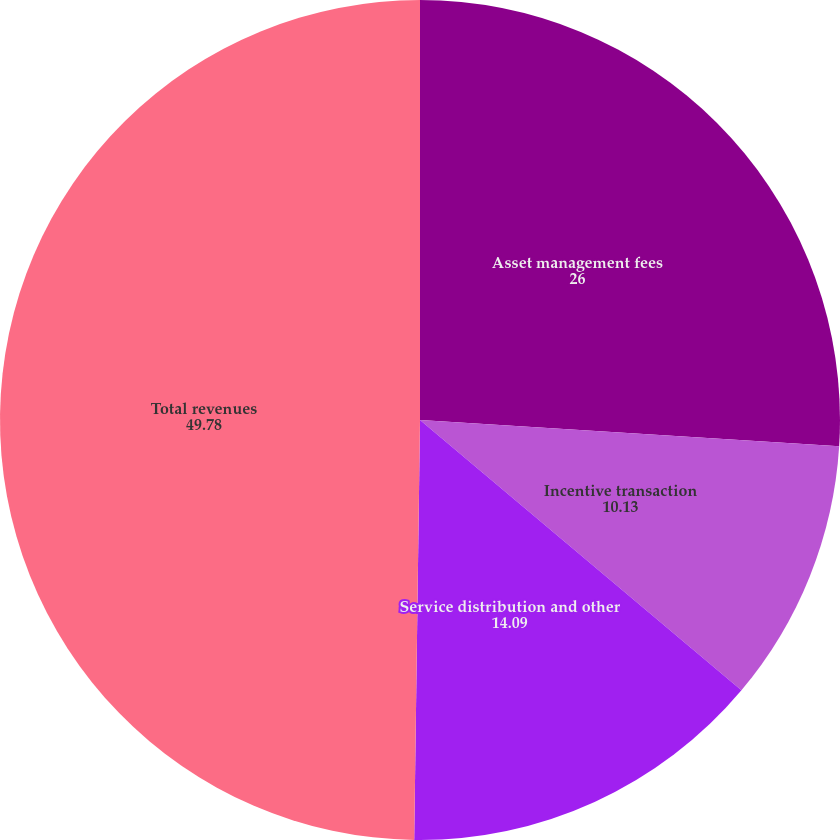Convert chart. <chart><loc_0><loc_0><loc_500><loc_500><pie_chart><fcel>Asset management fees<fcel>Incentive transaction<fcel>Service distribution and other<fcel>Total revenues<nl><fcel>26.0%<fcel>10.13%<fcel>14.09%<fcel>49.78%<nl></chart> 